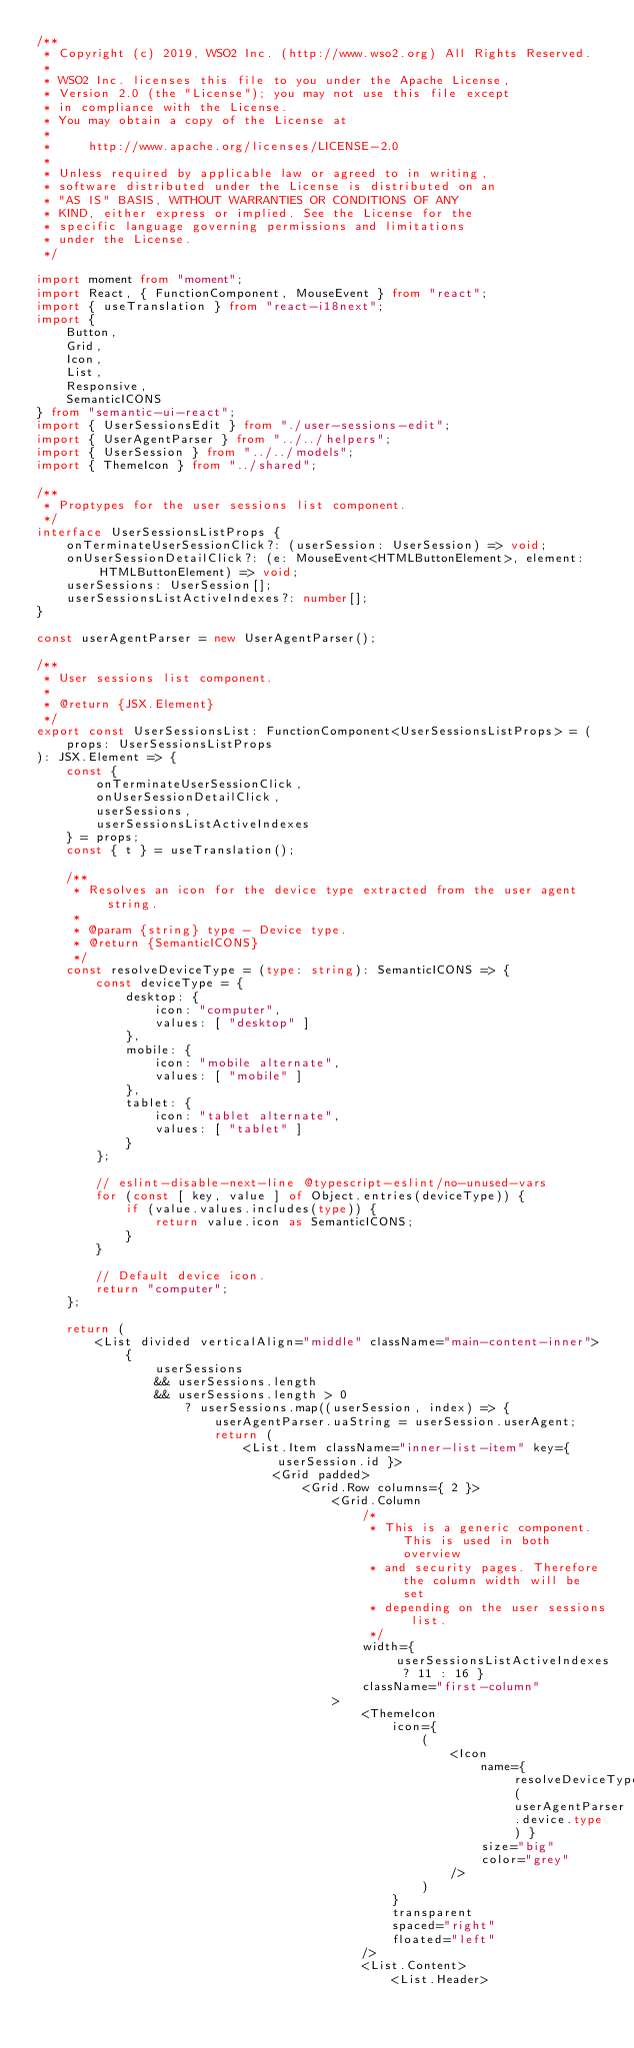Convert code to text. <code><loc_0><loc_0><loc_500><loc_500><_TypeScript_>/**
 * Copyright (c) 2019, WSO2 Inc. (http://www.wso2.org) All Rights Reserved.
 *
 * WSO2 Inc. licenses this file to you under the Apache License,
 * Version 2.0 (the "License"); you may not use this file except
 * in compliance with the License.
 * You may obtain a copy of the License at
 *
 *     http://www.apache.org/licenses/LICENSE-2.0
 *
 * Unless required by applicable law or agreed to in writing,
 * software distributed under the License is distributed on an
 * "AS IS" BASIS, WITHOUT WARRANTIES OR CONDITIONS OF ANY
 * KIND, either express or implied. See the License for the
 * specific language governing permissions and limitations
 * under the License.
 */

import moment from "moment";
import React, { FunctionComponent, MouseEvent } from "react";
import { useTranslation } from "react-i18next";
import {
    Button,
    Grid,
    Icon,
    List,
    Responsive,
    SemanticICONS
} from "semantic-ui-react";
import { UserSessionsEdit } from "./user-sessions-edit";
import { UserAgentParser } from "../../helpers";
import { UserSession } from "../../models";
import { ThemeIcon } from "../shared";

/**
 * Proptypes for the user sessions list component.
 */
interface UserSessionsListProps {
    onTerminateUserSessionClick?: (userSession: UserSession) => void;
    onUserSessionDetailClick?: (e: MouseEvent<HTMLButtonElement>, element: HTMLButtonElement) => void;
    userSessions: UserSession[];
    userSessionsListActiveIndexes?: number[];
}

const userAgentParser = new UserAgentParser();

/**
 * User sessions list component.
 *
 * @return {JSX.Element}
 */
export const UserSessionsList: FunctionComponent<UserSessionsListProps> = (
    props: UserSessionsListProps
): JSX.Element => {
    const {
        onTerminateUserSessionClick,
        onUserSessionDetailClick,
        userSessions,
        userSessionsListActiveIndexes
    } = props;
    const { t } = useTranslation();

    /**
     * Resolves an icon for the device type extracted from the user agent string.
     *
     * @param {string} type - Device type.
     * @return {SemanticICONS}
     */
    const resolveDeviceType = (type: string): SemanticICONS => {
        const deviceType = {
            desktop: {
                icon: "computer",
                values: [ "desktop" ]
            },
            mobile: {
                icon: "mobile alternate",
                values: [ "mobile" ]
            },
            tablet: {
                icon: "tablet alternate",
                values: [ "tablet" ]
            }
        };

        // eslint-disable-next-line @typescript-eslint/no-unused-vars
        for (const [ key, value ] of Object.entries(deviceType)) {
            if (value.values.includes(type)) {
                return value.icon as SemanticICONS;
            }
        }

        // Default device icon.
        return "computer";
    };

    return (
        <List divided verticalAlign="middle" className="main-content-inner">
            {
                userSessions
                && userSessions.length
                && userSessions.length > 0
                    ? userSessions.map((userSession, index) => {
                        userAgentParser.uaString = userSession.userAgent;
                        return (
                            <List.Item className="inner-list-item" key={ userSession.id }>
                                <Grid padded>
                                    <Grid.Row columns={ 2 }>
                                        <Grid.Column
                                            /*
                                             * This is a generic component. This is used in both overview
                                             * and security pages. Therefore the column width will be set
                                             * depending on the user sessions list.
                                             */
                                            width={ userSessionsListActiveIndexes ? 11 : 16 }
                                            className="first-column"
                                        >
                                            <ThemeIcon
                                                icon={
                                                    (
                                                        <Icon
                                                            name={ resolveDeviceType(userAgentParser.device.type) }
                                                            size="big"
                                                            color="grey"
                                                        />
                                                    )
                                                }
                                                transparent
                                                spaced="right"
                                                floated="left"
                                            />
                                            <List.Content>
                                                <List.Header></code> 